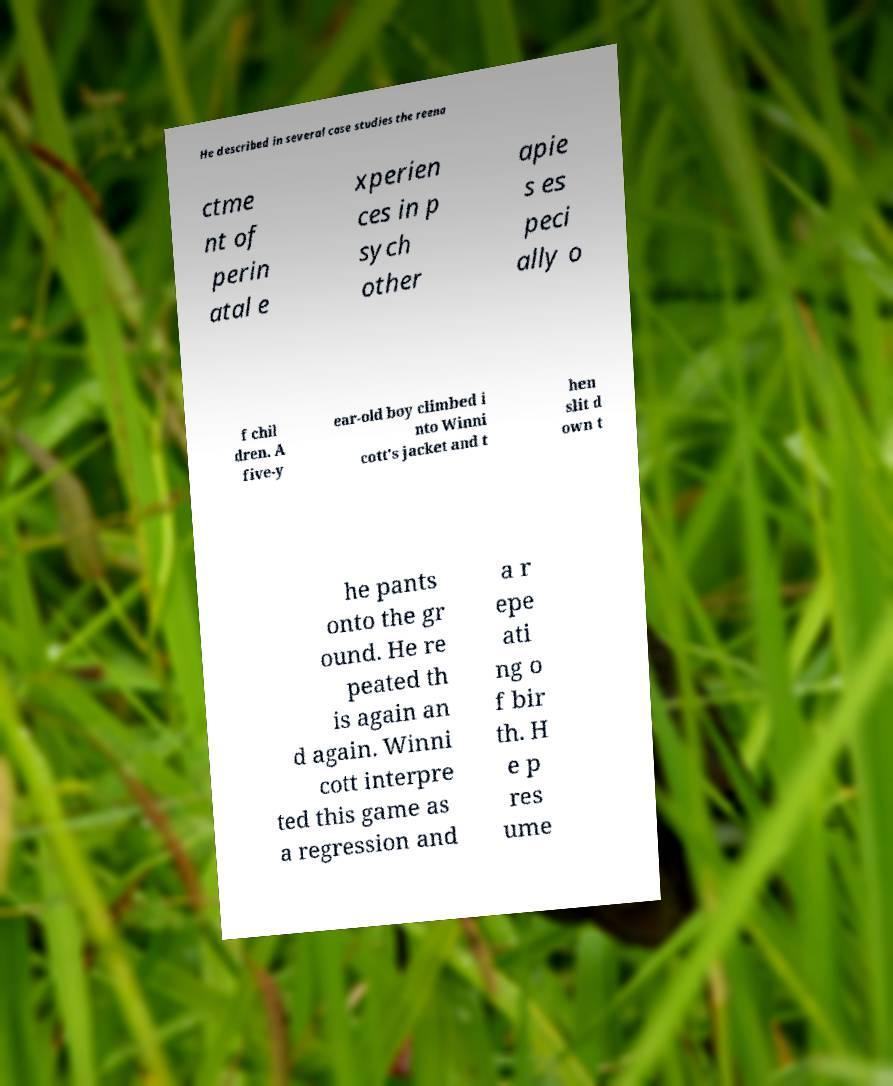Please read and relay the text visible in this image. What does it say? He described in several case studies the reena ctme nt of perin atal e xperien ces in p sych other apie s es peci ally o f chil dren. A five-y ear-old boy climbed i nto Winni cott's jacket and t hen slit d own t he pants onto the gr ound. He re peated th is again an d again. Winni cott interpre ted this game as a regression and a r epe ati ng o f bir th. H e p res ume 